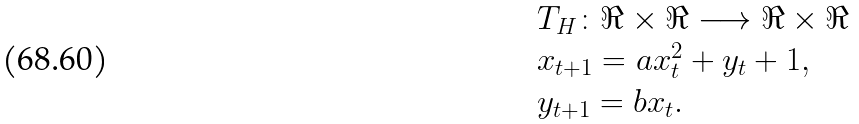Convert formula to latex. <formula><loc_0><loc_0><loc_500><loc_500>\begin{array} { l } T _ { H } \colon \Re \times \Re \longrightarrow \Re \times \Re \\ x _ { t + 1 } = a x _ { t } ^ { 2 } + y _ { t } + 1 , \\ y _ { t + 1 } = b x _ { t } . \end{array}</formula> 